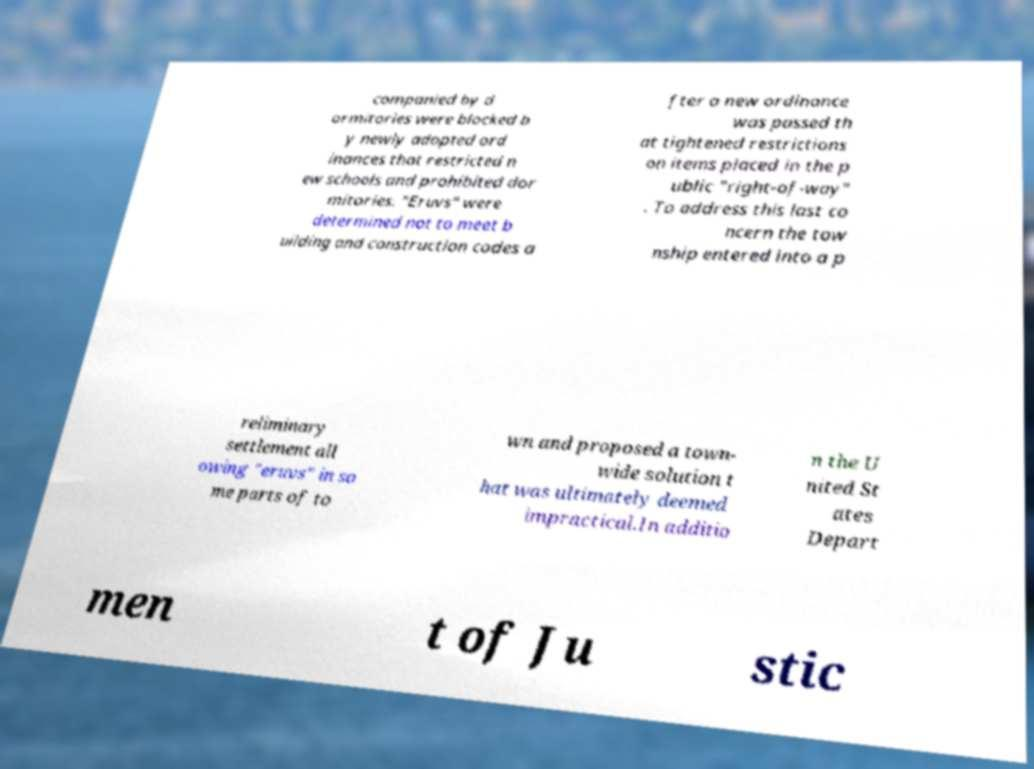Please read and relay the text visible in this image. What does it say? companied by d ormitories were blocked b y newly adopted ord inances that restricted n ew schools and prohibited dor mitories. "Eruvs" were determined not to meet b uilding and construction codes a fter a new ordinance was passed th at tightened restrictions on items placed in the p ublic "right-of-way" . To address this last co ncern the tow nship entered into a p reliminary settlement all owing "eruvs" in so me parts of to wn and proposed a town- wide solution t hat was ultimately deemed impractical.In additio n the U nited St ates Depart men t of Ju stic 